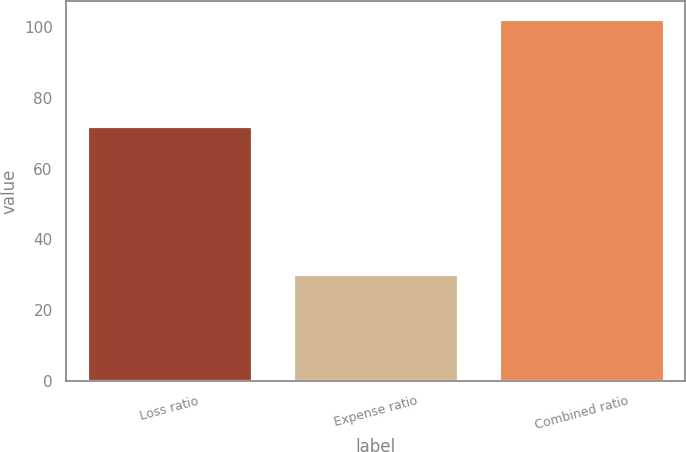<chart> <loc_0><loc_0><loc_500><loc_500><bar_chart><fcel>Loss ratio<fcel>Expense ratio<fcel>Combined ratio<nl><fcel>71.9<fcel>30.3<fcel>102.2<nl></chart> 